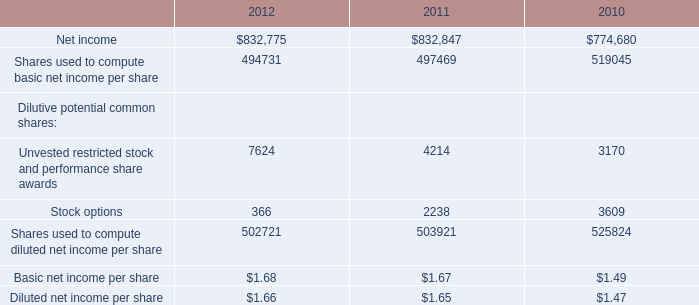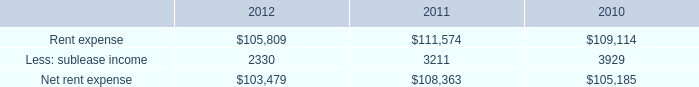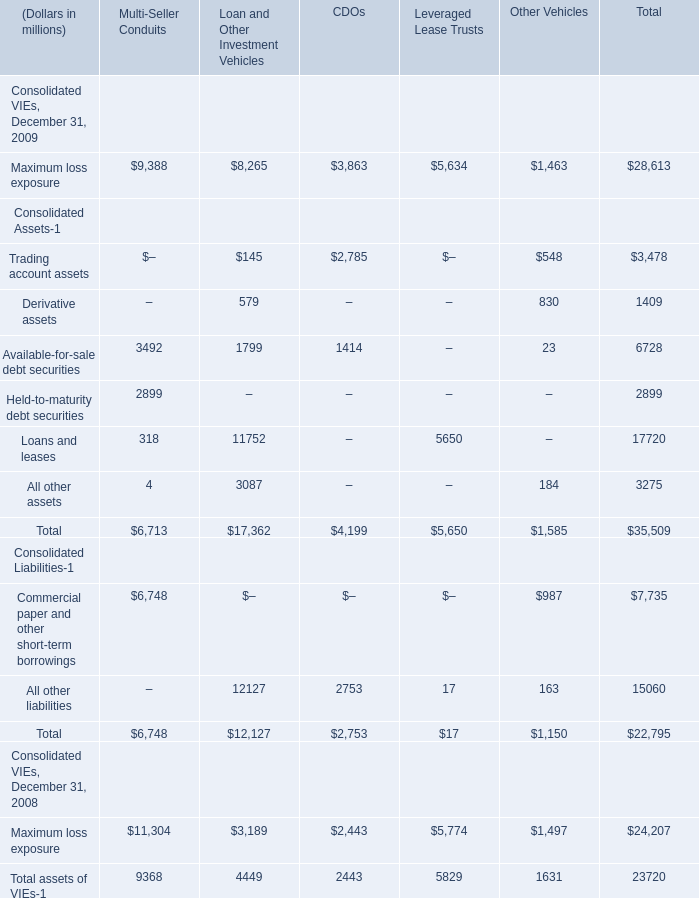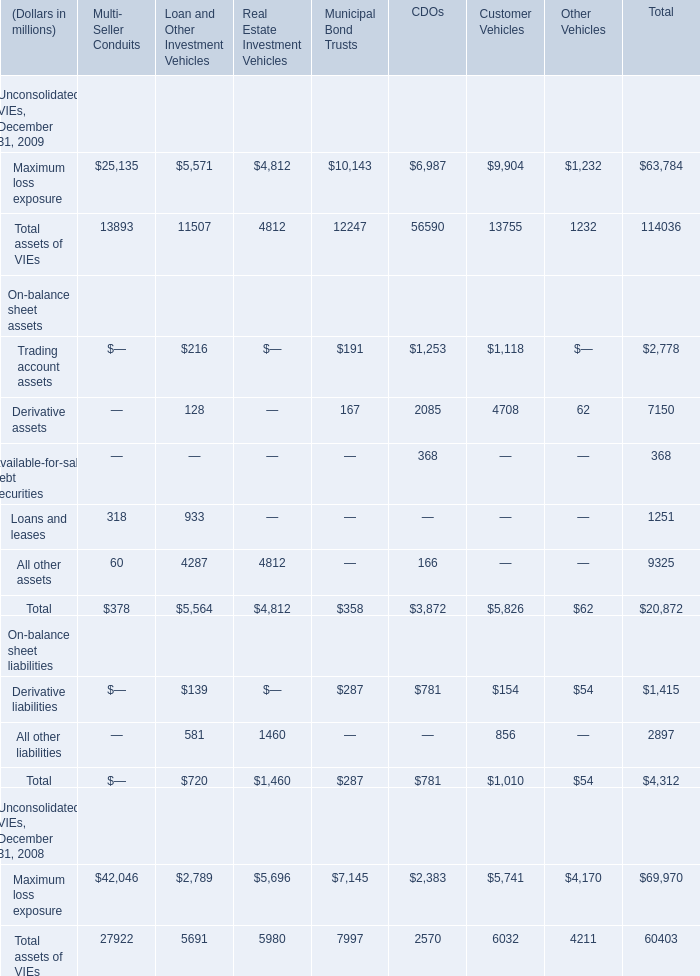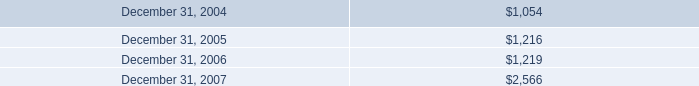What is the sum of the Maximum loss exposure in the years where Maximum loss exposure for Multi- Seller Conduits is greater than 26000? (in million) 
Computations: ((((((27922 + 5691) + 5980) + 7997) + 2570) + 6032) + 4211)
Answer: 60403.0. 